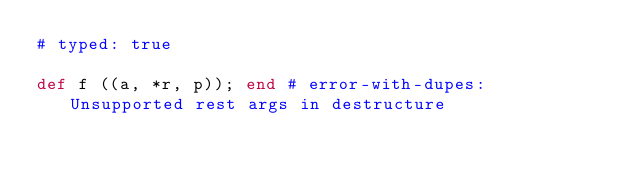Convert code to text. <code><loc_0><loc_0><loc_500><loc_500><_Ruby_># typed: true

def f ((a, *r, p)); end # error-with-dupes: Unsupported rest args in destructure
</code> 